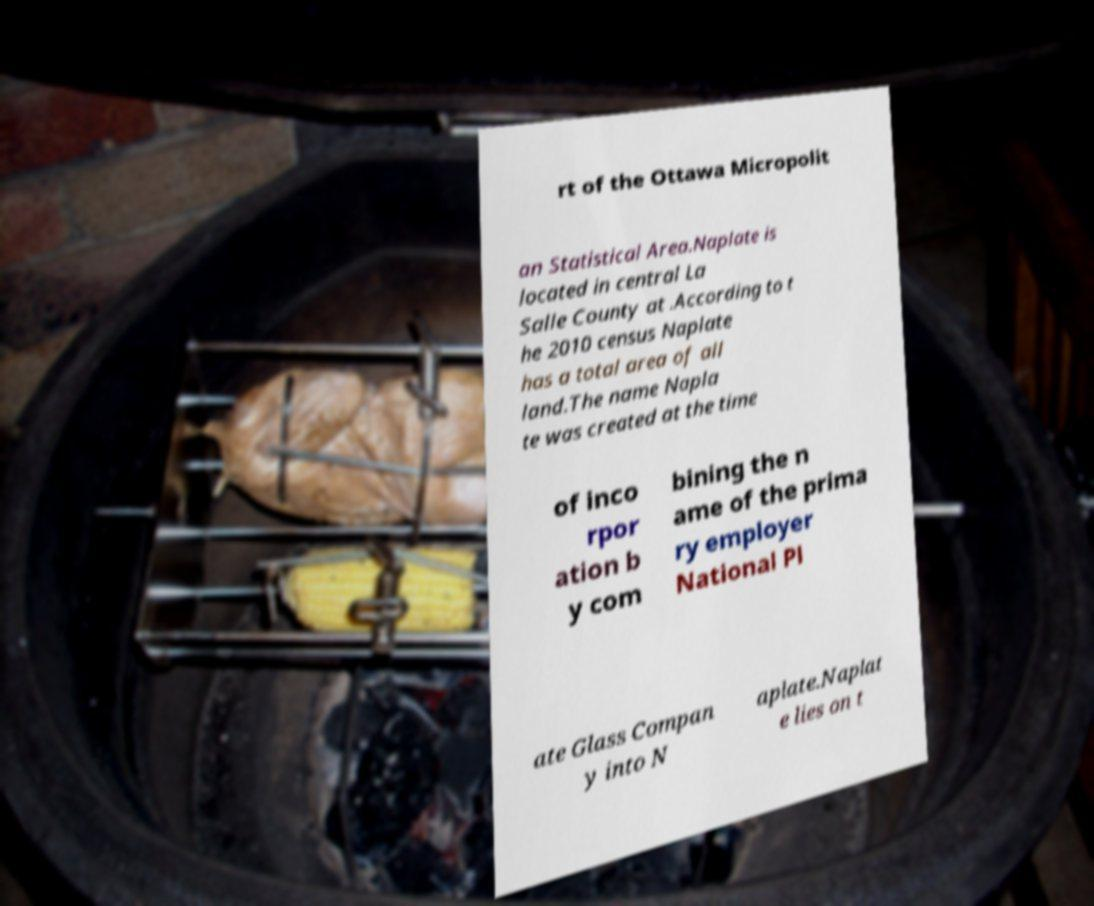Could you extract and type out the text from this image? rt of the Ottawa Micropolit an Statistical Area.Naplate is located in central La Salle County at .According to t he 2010 census Naplate has a total area of all land.The name Napla te was created at the time of inco rpor ation b y com bining the n ame of the prima ry employer National Pl ate Glass Compan y into N aplate.Naplat e lies on t 